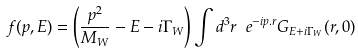Convert formula to latex. <formula><loc_0><loc_0><loc_500><loc_500>f ( { p } , E ) = \left ( \frac { p ^ { 2 } } { M _ { W } } - E - i \Gamma _ { W } \right ) \int d ^ { 3 } r \ e ^ { - i { p } . { r } } G _ { E + i \Gamma _ { W } } ( { r } , 0 )</formula> 